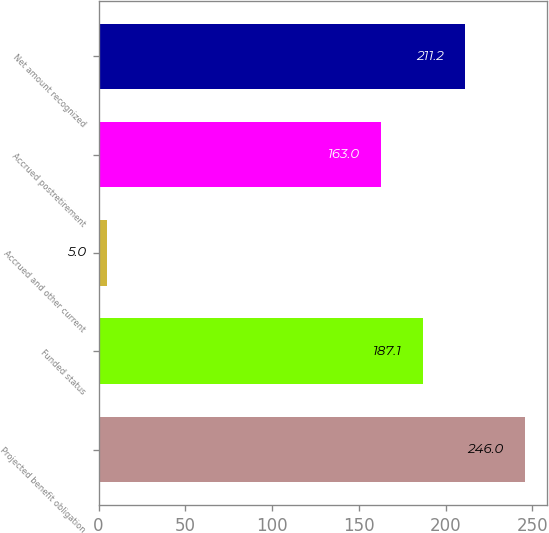Convert chart to OTSL. <chart><loc_0><loc_0><loc_500><loc_500><bar_chart><fcel>Projected benefit obligation<fcel>Funded status<fcel>Accrued and other current<fcel>Accrued postretirement<fcel>Net amount recognized<nl><fcel>246<fcel>187.1<fcel>5<fcel>163<fcel>211.2<nl></chart> 